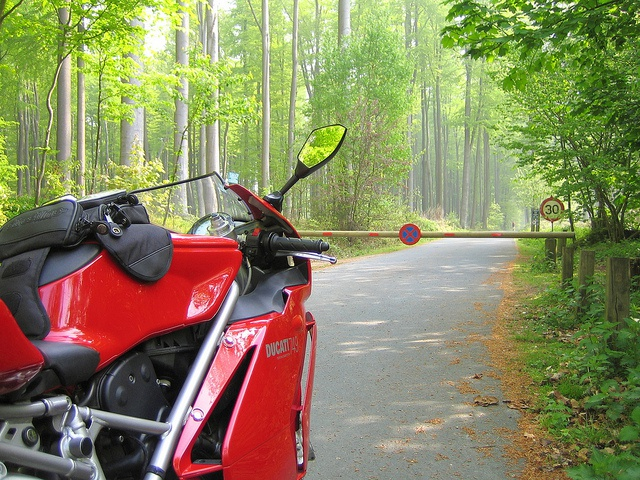Describe the objects in this image and their specific colors. I can see a motorcycle in darkgreen, black, brown, and gray tones in this image. 